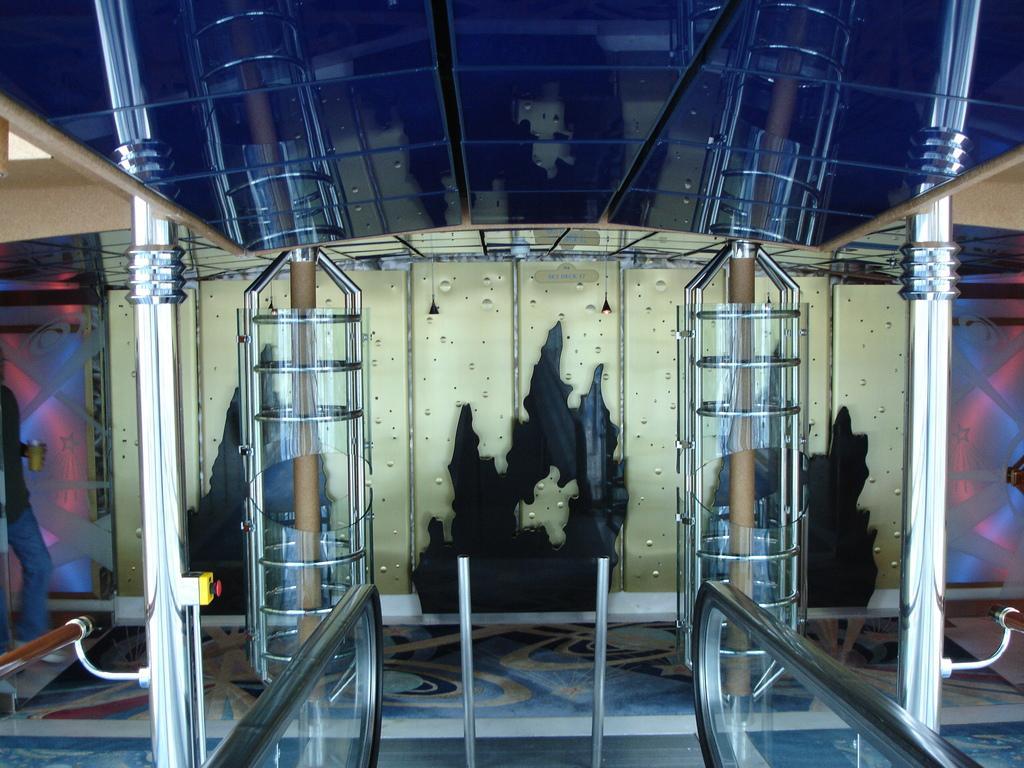In one or two sentences, can you explain what this image depicts? In this image in the center there are some poles and some glass poles, at the bottom there are two rods and two glass boards. And in the background it looks like a wall, and in the center of the image there is something. And at the top of the image there is a glass board, and on the board we could see reflection of some poles and some other objects. And on the left side of the image there is one person standing, and he is holding a cup and on the right side and left side there are some boards and some other objects. At the bottom there is floor. 